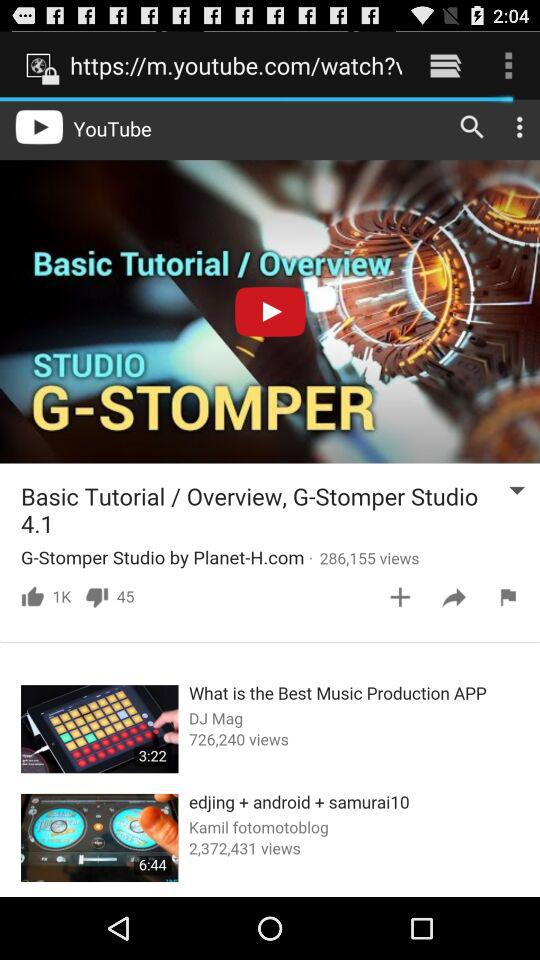How many likes did "G-Stomper Studio by Planet-H.com" get? "G-Stomper Studio by Planet-H.com" gets 1k likes. 